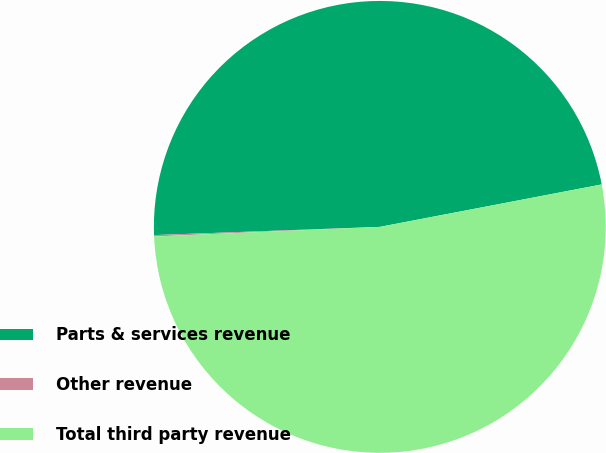<chart> <loc_0><loc_0><loc_500><loc_500><pie_chart><fcel>Parts & services revenue<fcel>Other revenue<fcel>Total third party revenue<nl><fcel>47.57%<fcel>0.1%<fcel>52.33%<nl></chart> 